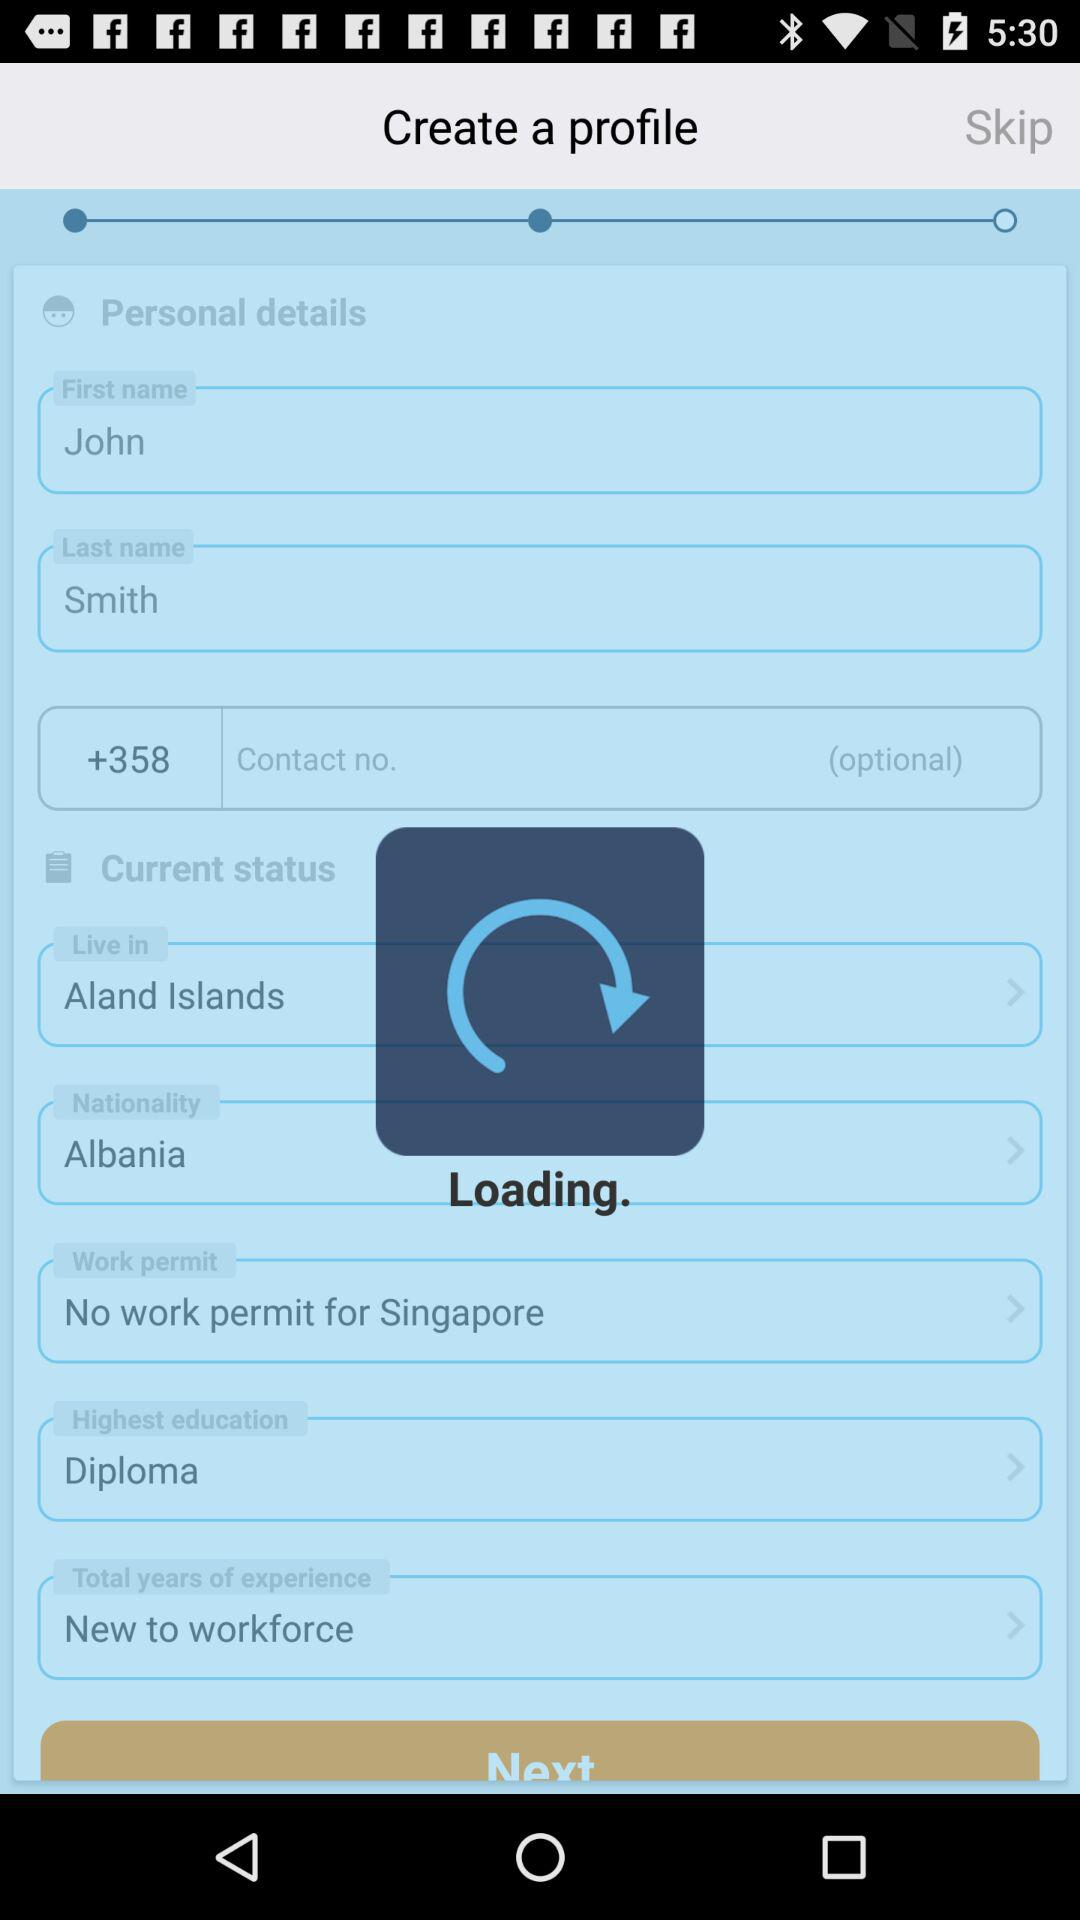What is the first name? The first name is John. 